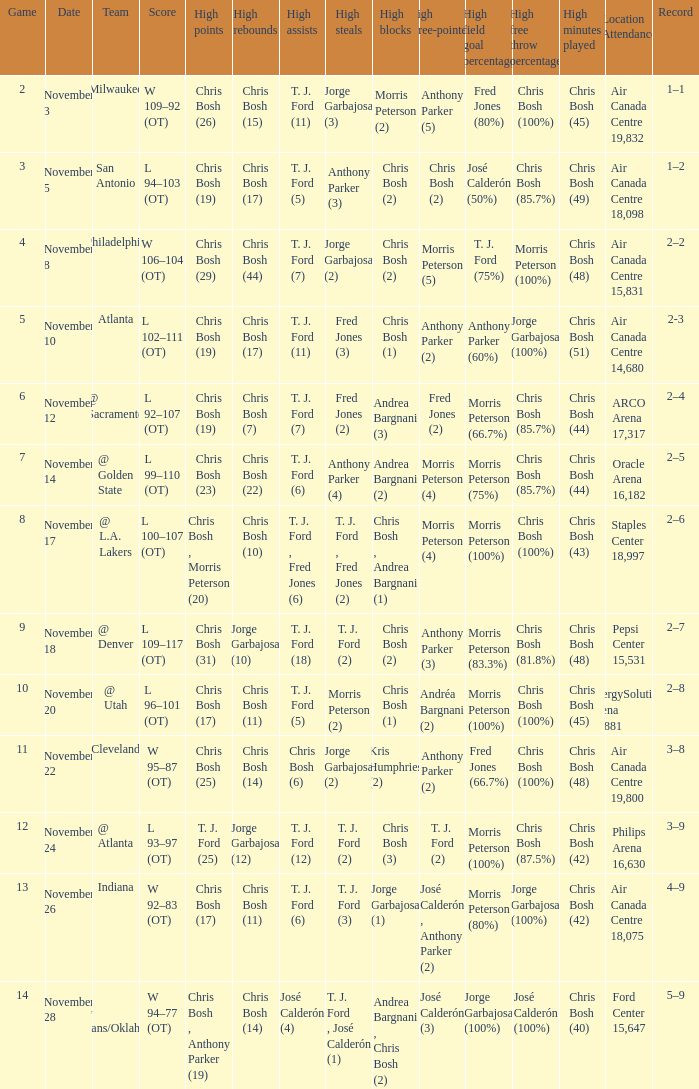Where was the game on November 20? EnergySolutions Arena 18,881. 